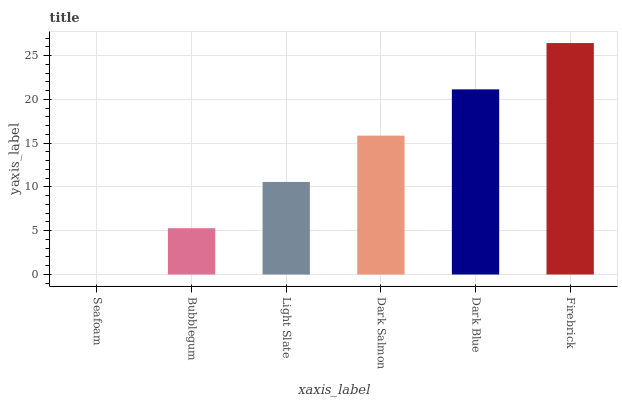Is Seafoam the minimum?
Answer yes or no. Yes. Is Firebrick the maximum?
Answer yes or no. Yes. Is Bubblegum the minimum?
Answer yes or no. No. Is Bubblegum the maximum?
Answer yes or no. No. Is Bubblegum greater than Seafoam?
Answer yes or no. Yes. Is Seafoam less than Bubblegum?
Answer yes or no. Yes. Is Seafoam greater than Bubblegum?
Answer yes or no. No. Is Bubblegum less than Seafoam?
Answer yes or no. No. Is Dark Salmon the high median?
Answer yes or no. Yes. Is Light Slate the low median?
Answer yes or no. Yes. Is Seafoam the high median?
Answer yes or no. No. Is Seafoam the low median?
Answer yes or no. No. 